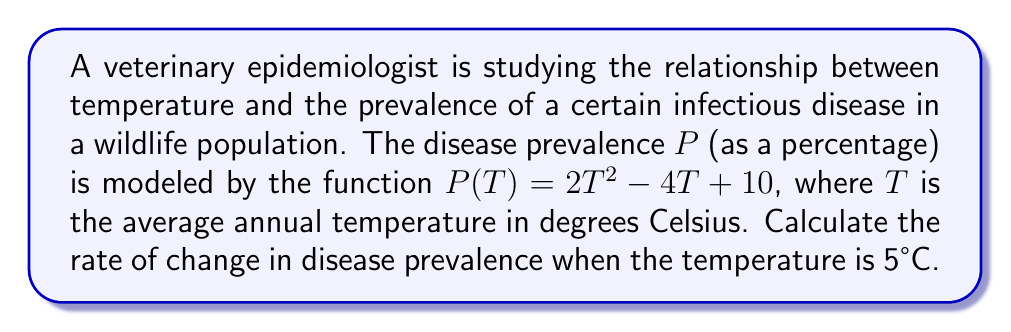Show me your answer to this math problem. To solve this problem, we need to find the derivative of the given function and evaluate it at the specified temperature.

1) The function for disease prevalence is:
   $$P(T) = 2T^2 - 4T + 10$$

2) To find the rate of change, we need to calculate the derivative $P'(T)$:
   $$P'(T) = \frac{d}{dT}(2T^2 - 4T + 10)$$

3) Using the power rule and the constant rule of differentiation:
   $$P'(T) = 2 \cdot 2T^{2-1} - 4 + 0$$
   $$P'(T) = 4T - 4$$

4) This derivative $P'(T)$ represents the rate of change of disease prevalence with respect to temperature.

5) To find the rate of change at 5°C, we substitute $T = 5$ into the derivative:
   $$P'(5) = 4(5) - 4 = 20 - 4 = 16$$

Therefore, when the temperature is 5°C, the rate of change in disease prevalence is 16% per °C.
Answer: 16% per °C 